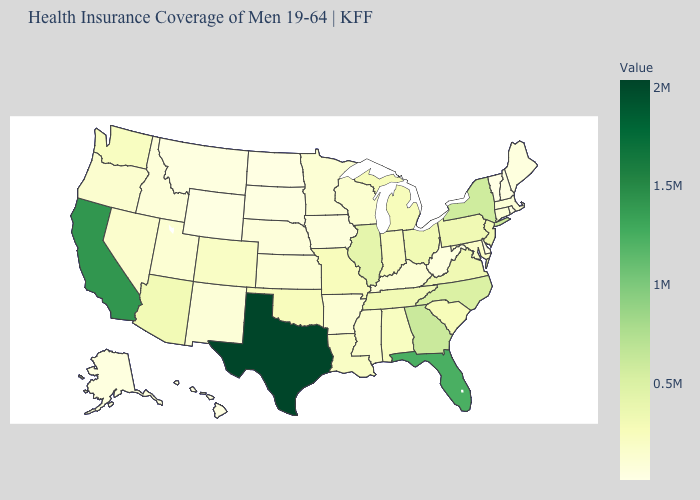Is the legend a continuous bar?
Quick response, please. Yes. Which states have the highest value in the USA?
Quick response, please. Texas. Which states hav the highest value in the West?
Quick response, please. California. Is the legend a continuous bar?
Write a very short answer. Yes. 